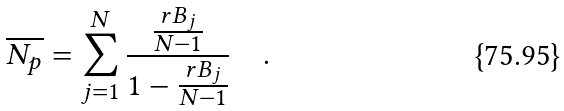<formula> <loc_0><loc_0><loc_500><loc_500>\overline { N _ { p } } = \sum _ { j = 1 } ^ { N } \frac { \frac { r B _ { j } } { N - 1 } } { 1 - \frac { r B _ { j } } { N - 1 } } \quad .</formula> 